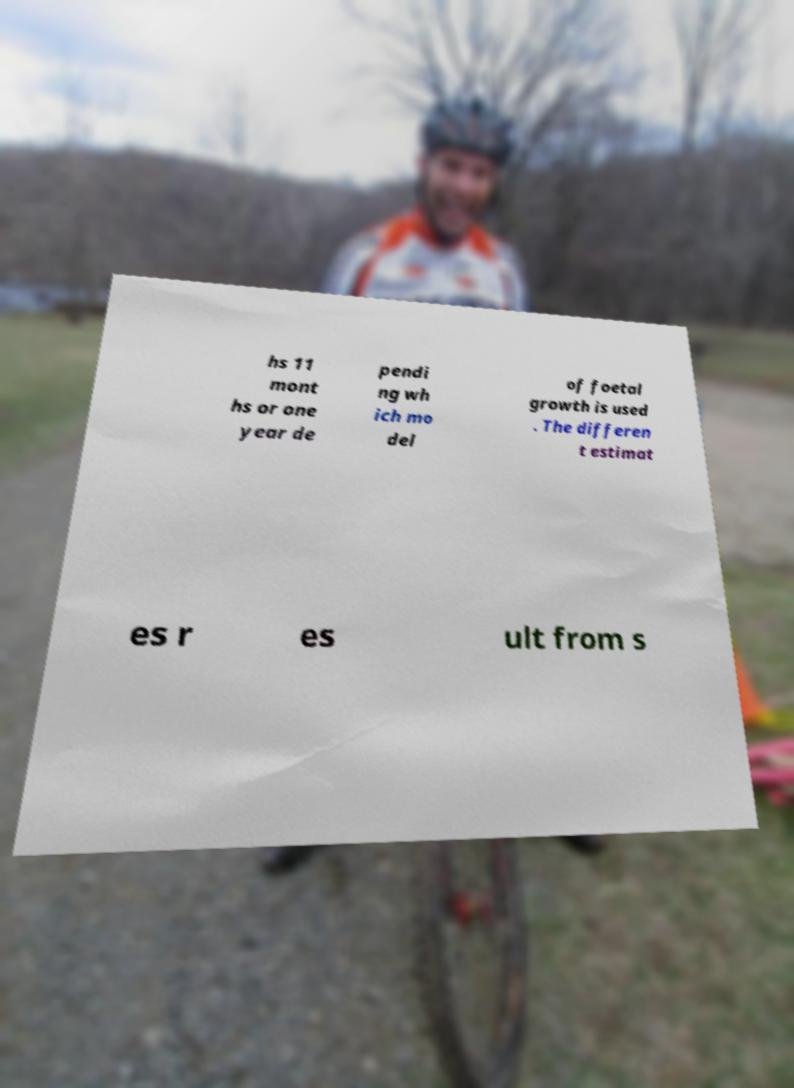Could you assist in decoding the text presented in this image and type it out clearly? hs 11 mont hs or one year de pendi ng wh ich mo del of foetal growth is used . The differen t estimat es r es ult from s 